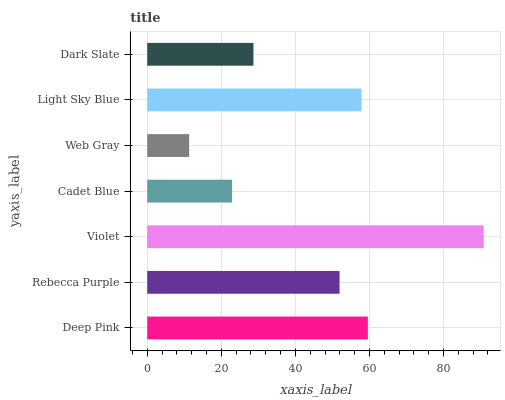Is Web Gray the minimum?
Answer yes or no. Yes. Is Violet the maximum?
Answer yes or no. Yes. Is Rebecca Purple the minimum?
Answer yes or no. No. Is Rebecca Purple the maximum?
Answer yes or no. No. Is Deep Pink greater than Rebecca Purple?
Answer yes or no. Yes. Is Rebecca Purple less than Deep Pink?
Answer yes or no. Yes. Is Rebecca Purple greater than Deep Pink?
Answer yes or no. No. Is Deep Pink less than Rebecca Purple?
Answer yes or no. No. Is Rebecca Purple the high median?
Answer yes or no. Yes. Is Rebecca Purple the low median?
Answer yes or no. Yes. Is Light Sky Blue the high median?
Answer yes or no. No. Is Web Gray the low median?
Answer yes or no. No. 